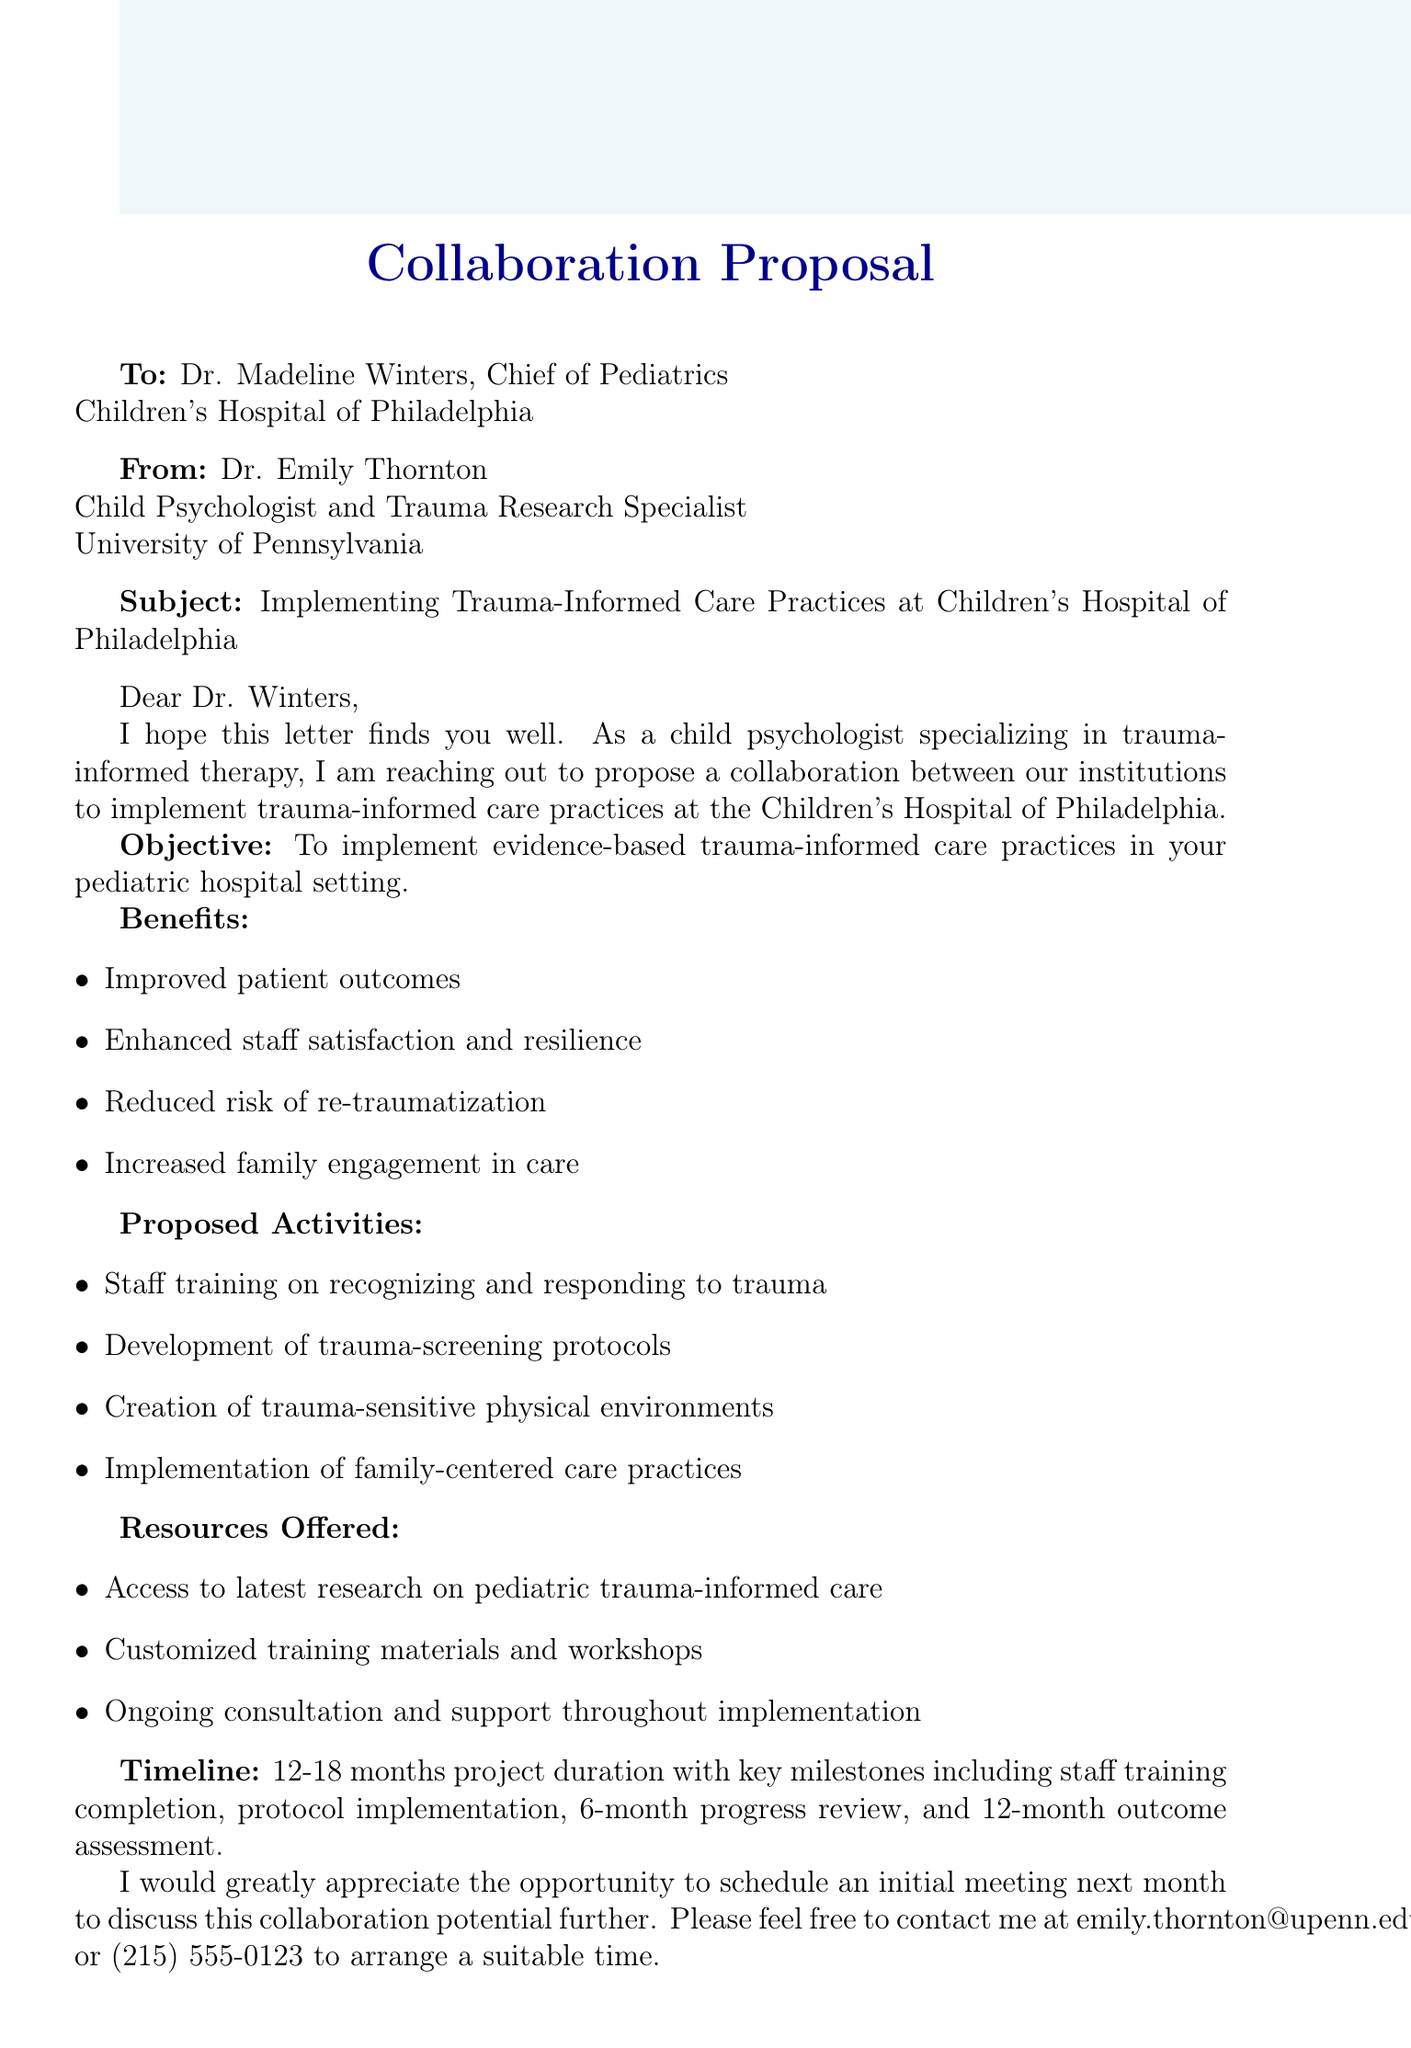What is the subject of the email? The subject of the email is presented at the top of the document, indicating the main topic of discussion.
Answer: Collaboration Proposal: Implementing Trauma-Informed Care Practices at Children's Hospital of Philadelphia Who is the recipient of the email? The recipient's name and position are specified in the document, directly indicating whom the email is addressed to.
Answer: Dr. Madeline Winters What is the primary objective of the proposed collaboration? The objective is clearly stated in the document and provides insight into the aim of the proposed collaboration.
Answer: Implementation of trauma-informed care practices in the pediatric hospital setting How long is the projected project duration? The document gives a specific timeframe for how long the project is anticipated to last.
Answer: 12-18 months What are two benefits of implementing trauma-informed care? The benefits listed in the document highlight the positive outcomes expected from the collaboration.
Answer: Improved patient outcomes and enhanced staff satisfaction What activities are proposed for the collaboration? Specific activities to be undertaken are outlined in the document, providing insight into how the collaboration will take shape.
Answer: Staff training on recognizing and responding to trauma What resources will be offered by Dr. Emily Thornton? The resources offered are mentioned in the document, detailing what support will be available during the collaboration.
Answer: Access to latest research on pediatric trauma-informed care When is the initial meeting proposed to take place? The proposed timing for the initial meeting is stated in the document, indicating the next steps for collaboration.
Answer: Next month What is the email contact provided for scheduling the meeting? The document includes specific contact information for follow-up communication regarding the meeting.
Answer: emily.thornton@upenn.edu 